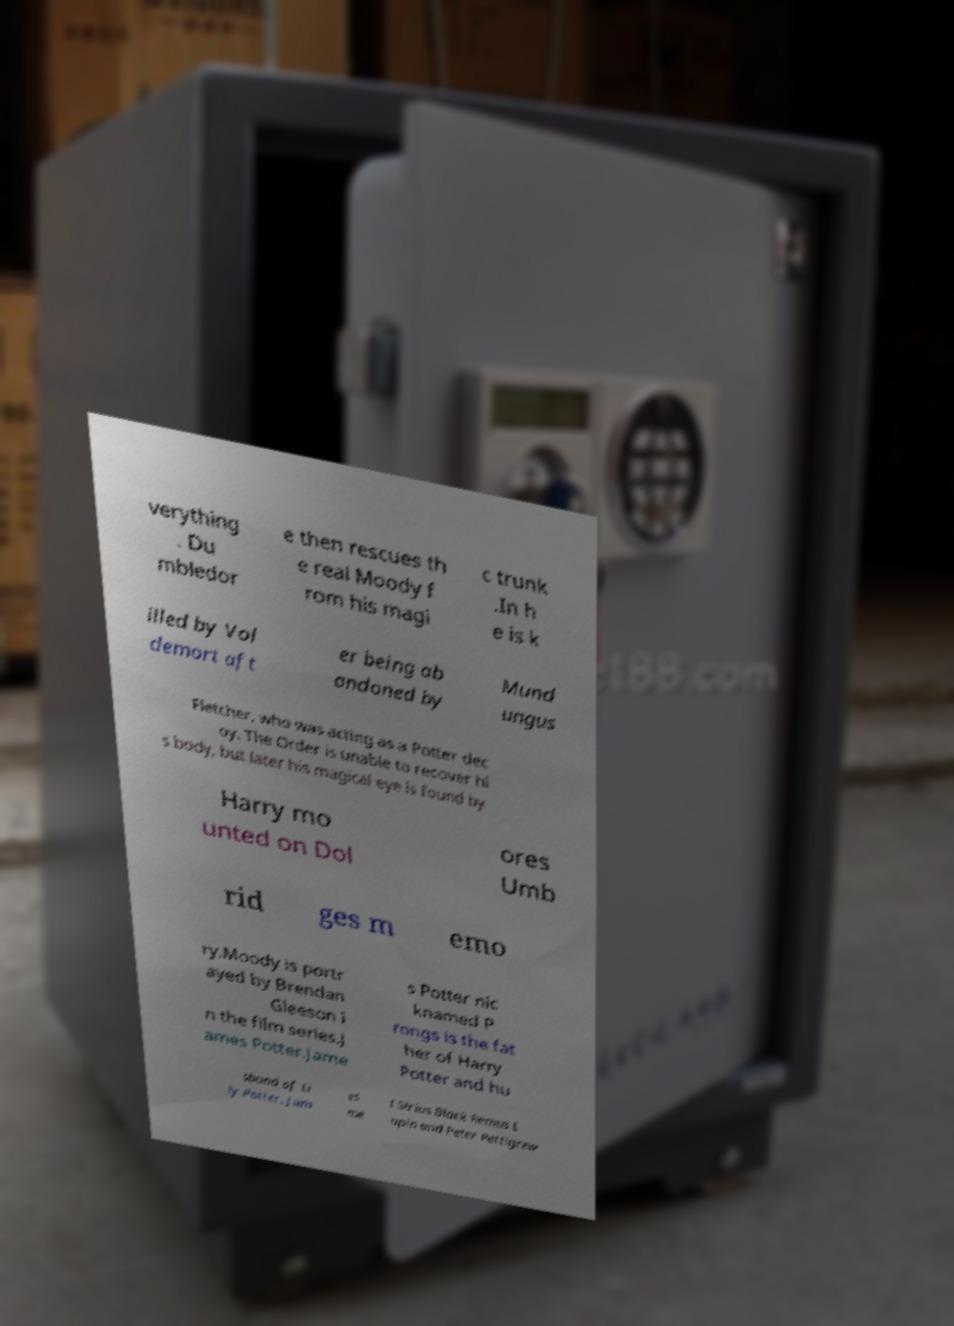Can you read and provide the text displayed in the image?This photo seems to have some interesting text. Can you extract and type it out for me? verything . Du mbledor e then rescues th e real Moody f rom his magi c trunk .In h e is k illed by Vol demort aft er being ab andoned by Mund ungus Fletcher, who was acting as a Potter dec oy. The Order is unable to recover hi s body, but later his magical eye is found by Harry mo unted on Dol ores Umb rid ges m emo ry.Moody is portr ayed by Brendan Gleeson i n the film series.J ames Potter.Jame s Potter nic knamed P rongs is the fat her of Harry Potter and hu sband of Li ly Potter. Jam es me t Sirius Black Remus L upin and Peter Pettigrew 